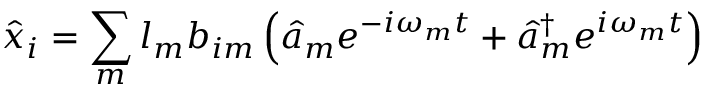Convert formula to latex. <formula><loc_0><loc_0><loc_500><loc_500>\hat { x } _ { i } = \sum _ { m } l _ { m } b _ { i m } \left ( \hat { a } _ { m } e ^ { - i \omega _ { m } t } + \hat { a } _ { m } ^ { \dagger } e ^ { i \omega _ { m } t } \right )</formula> 